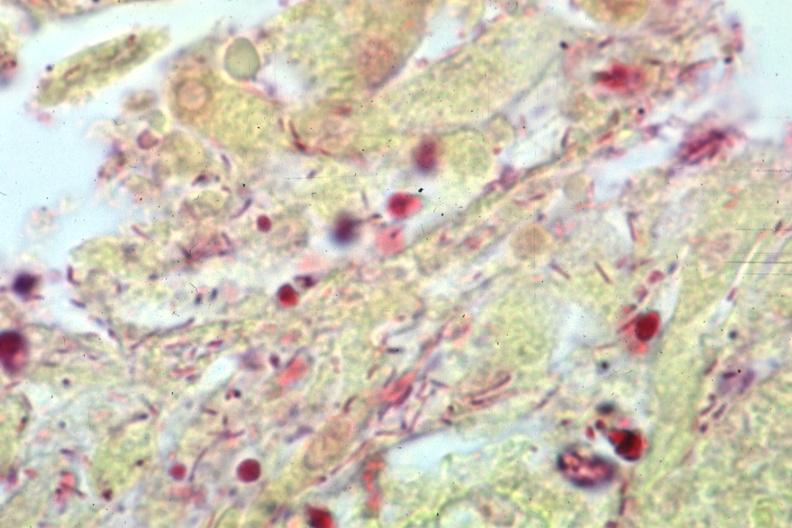does placenta show gram stain gram negative bacteria?
Answer the question using a single word or phrase. No 